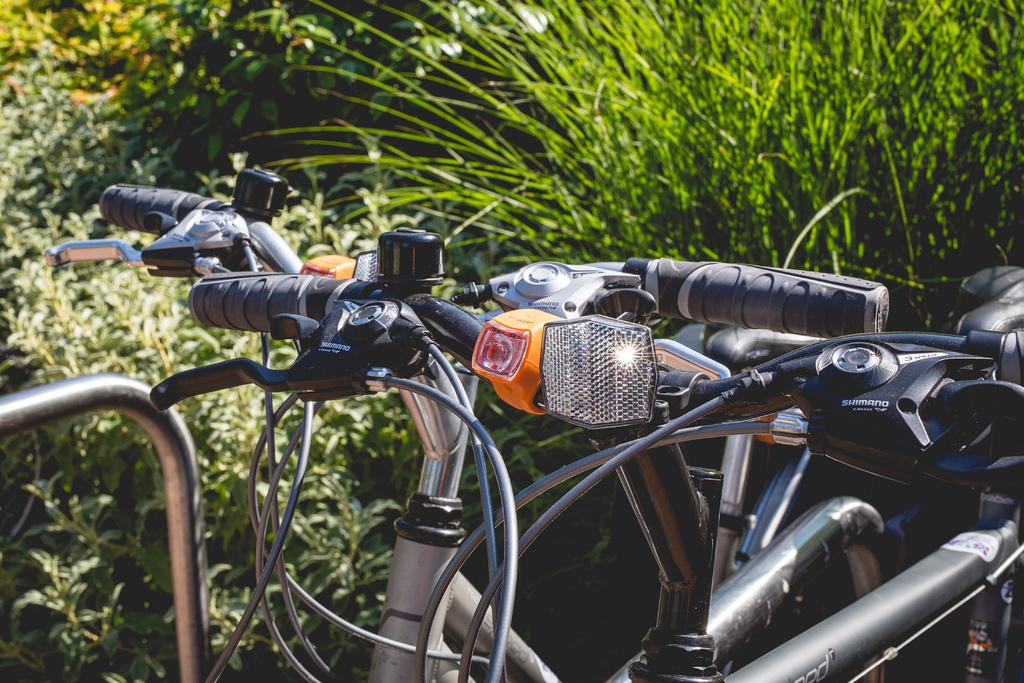Where was the image taken? The image was taken outdoors. What can be seen in the background of the image? There are trees and plants in the background of the image. What object is parked on the right side of the image? A bike is parked on the ground on the right side of the image. What type of collar can be seen on the bike in the image? There is no collar present on the bike in the image. What is the aftermath of the battle depicted in the image? There is no battle depicted in the image; it features a bike parked outdoors with trees and plants in the background. 